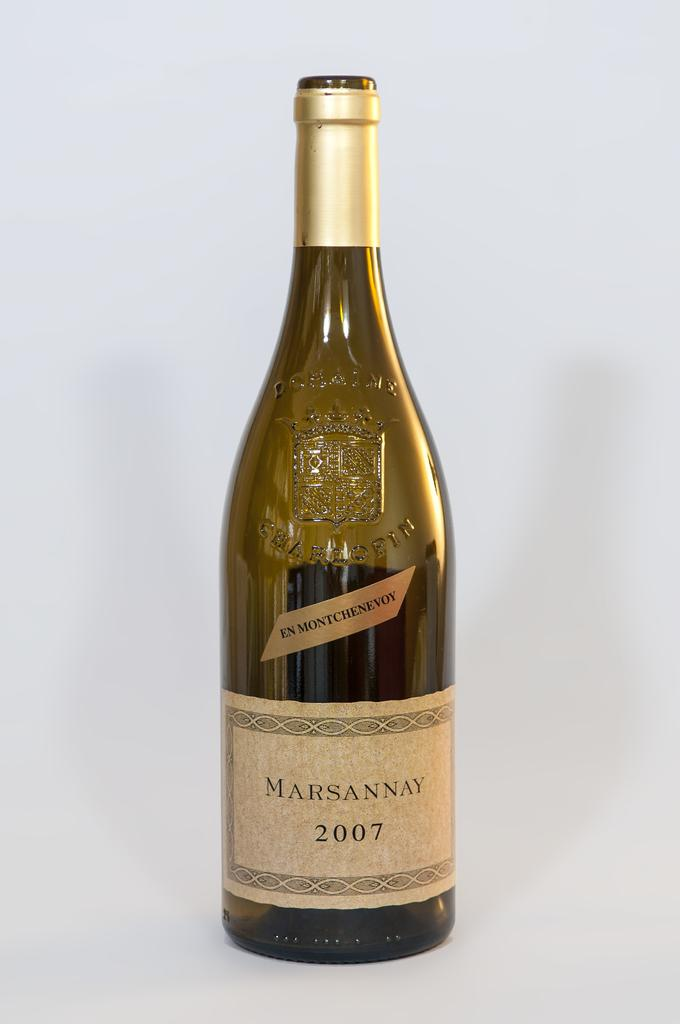<image>
Render a clear and concise summary of the photo. A bottle of Marsannay from 2007 against a white backdrop. 